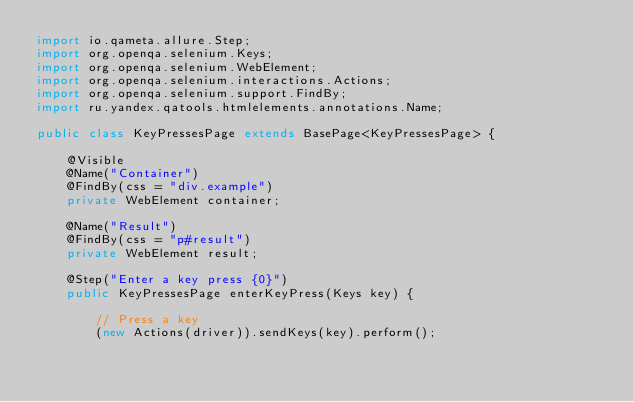Convert code to text. <code><loc_0><loc_0><loc_500><loc_500><_Java_>import io.qameta.allure.Step;
import org.openqa.selenium.Keys;
import org.openqa.selenium.WebElement;
import org.openqa.selenium.interactions.Actions;
import org.openqa.selenium.support.FindBy;
import ru.yandex.qatools.htmlelements.annotations.Name;

public class KeyPressesPage extends BasePage<KeyPressesPage> {

    @Visible
    @Name("Container")
    @FindBy(css = "div.example")
    private WebElement container;

    @Name("Result")
    @FindBy(css = "p#result")
    private WebElement result;

    @Step("Enter a key press {0}")
    public KeyPressesPage enterKeyPress(Keys key) {

        // Press a key
        (new Actions(driver)).sendKeys(key).perform();
</code> 